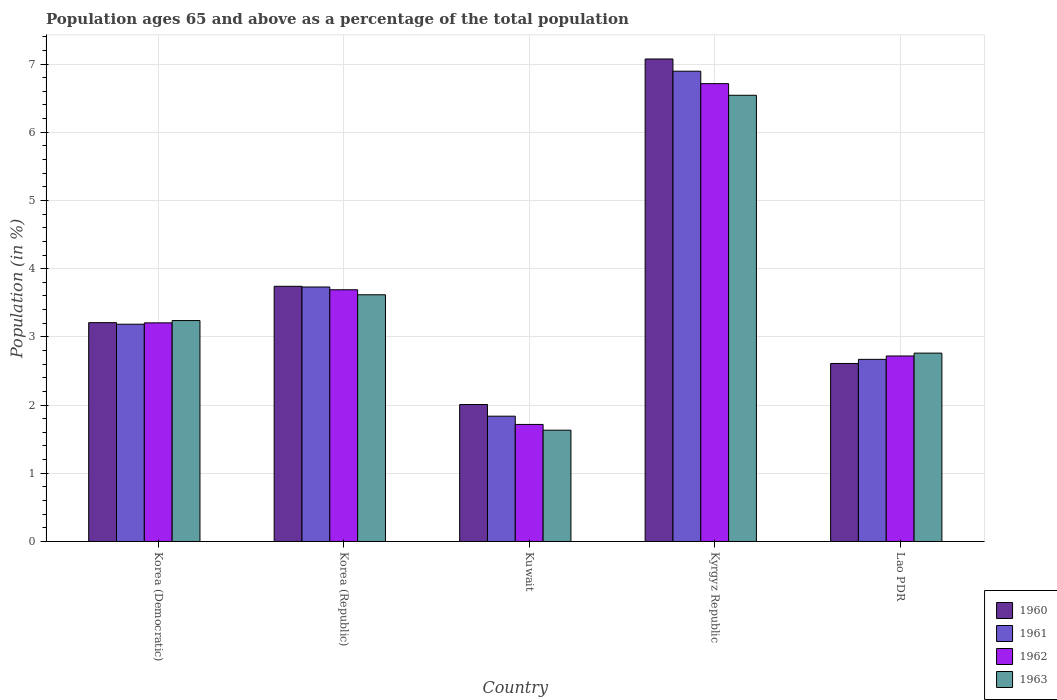How many groups of bars are there?
Offer a very short reply. 5. Are the number of bars on each tick of the X-axis equal?
Provide a short and direct response. Yes. How many bars are there on the 3rd tick from the left?
Ensure brevity in your answer.  4. What is the label of the 4th group of bars from the left?
Provide a short and direct response. Kyrgyz Republic. In how many cases, is the number of bars for a given country not equal to the number of legend labels?
Offer a very short reply. 0. What is the percentage of the population ages 65 and above in 1960 in Lao PDR?
Keep it short and to the point. 2.61. Across all countries, what is the maximum percentage of the population ages 65 and above in 1960?
Offer a very short reply. 7.07. Across all countries, what is the minimum percentage of the population ages 65 and above in 1960?
Make the answer very short. 2.01. In which country was the percentage of the population ages 65 and above in 1960 maximum?
Offer a terse response. Kyrgyz Republic. In which country was the percentage of the population ages 65 and above in 1960 minimum?
Provide a succinct answer. Kuwait. What is the total percentage of the population ages 65 and above in 1961 in the graph?
Make the answer very short. 18.32. What is the difference between the percentage of the population ages 65 and above in 1962 in Korea (Democratic) and that in Kyrgyz Republic?
Your response must be concise. -3.51. What is the difference between the percentage of the population ages 65 and above in 1963 in Kuwait and the percentage of the population ages 65 and above in 1962 in Lao PDR?
Your answer should be compact. -1.09. What is the average percentage of the population ages 65 and above in 1960 per country?
Offer a terse response. 3.73. What is the difference between the percentage of the population ages 65 and above of/in 1962 and percentage of the population ages 65 and above of/in 1961 in Korea (Democratic)?
Your answer should be very brief. 0.02. In how many countries, is the percentage of the population ages 65 and above in 1962 greater than 2.6?
Your answer should be compact. 4. What is the ratio of the percentage of the population ages 65 and above in 1960 in Korea (Republic) to that in Lao PDR?
Give a very brief answer. 1.43. Is the percentage of the population ages 65 and above in 1960 in Korea (Republic) less than that in Kyrgyz Republic?
Offer a terse response. Yes. What is the difference between the highest and the second highest percentage of the population ages 65 and above in 1963?
Your response must be concise. -0.38. What is the difference between the highest and the lowest percentage of the population ages 65 and above in 1960?
Provide a succinct answer. 5.07. In how many countries, is the percentage of the population ages 65 and above in 1962 greater than the average percentage of the population ages 65 and above in 1962 taken over all countries?
Keep it short and to the point. 2. Is it the case that in every country, the sum of the percentage of the population ages 65 and above in 1961 and percentage of the population ages 65 and above in 1960 is greater than the sum of percentage of the population ages 65 and above in 1963 and percentage of the population ages 65 and above in 1962?
Your response must be concise. No. What does the 4th bar from the left in Kyrgyz Republic represents?
Your answer should be compact. 1963. What does the 1st bar from the right in Kyrgyz Republic represents?
Offer a terse response. 1963. Are all the bars in the graph horizontal?
Offer a very short reply. No. How many countries are there in the graph?
Your answer should be compact. 5. What is the difference between two consecutive major ticks on the Y-axis?
Your answer should be compact. 1. Are the values on the major ticks of Y-axis written in scientific E-notation?
Your answer should be compact. No. What is the title of the graph?
Give a very brief answer. Population ages 65 and above as a percentage of the total population. What is the label or title of the X-axis?
Your answer should be compact. Country. What is the Population (in %) in 1960 in Korea (Democratic)?
Provide a short and direct response. 3.21. What is the Population (in %) in 1961 in Korea (Democratic)?
Your answer should be compact. 3.19. What is the Population (in %) in 1962 in Korea (Democratic)?
Make the answer very short. 3.21. What is the Population (in %) of 1963 in Korea (Democratic)?
Make the answer very short. 3.24. What is the Population (in %) of 1960 in Korea (Republic)?
Your answer should be very brief. 3.74. What is the Population (in %) of 1961 in Korea (Republic)?
Your answer should be very brief. 3.73. What is the Population (in %) of 1962 in Korea (Republic)?
Make the answer very short. 3.69. What is the Population (in %) in 1963 in Korea (Republic)?
Ensure brevity in your answer.  3.62. What is the Population (in %) of 1960 in Kuwait?
Keep it short and to the point. 2.01. What is the Population (in %) of 1961 in Kuwait?
Your answer should be compact. 1.84. What is the Population (in %) of 1962 in Kuwait?
Offer a terse response. 1.72. What is the Population (in %) in 1963 in Kuwait?
Your answer should be compact. 1.63. What is the Population (in %) of 1960 in Kyrgyz Republic?
Offer a very short reply. 7.07. What is the Population (in %) in 1961 in Kyrgyz Republic?
Offer a terse response. 6.9. What is the Population (in %) of 1962 in Kyrgyz Republic?
Keep it short and to the point. 6.71. What is the Population (in %) in 1963 in Kyrgyz Republic?
Provide a short and direct response. 6.54. What is the Population (in %) of 1960 in Lao PDR?
Ensure brevity in your answer.  2.61. What is the Population (in %) of 1961 in Lao PDR?
Your response must be concise. 2.67. What is the Population (in %) of 1962 in Lao PDR?
Provide a succinct answer. 2.72. What is the Population (in %) in 1963 in Lao PDR?
Give a very brief answer. 2.76. Across all countries, what is the maximum Population (in %) of 1960?
Offer a very short reply. 7.07. Across all countries, what is the maximum Population (in %) in 1961?
Keep it short and to the point. 6.9. Across all countries, what is the maximum Population (in %) of 1962?
Give a very brief answer. 6.71. Across all countries, what is the maximum Population (in %) in 1963?
Ensure brevity in your answer.  6.54. Across all countries, what is the minimum Population (in %) in 1960?
Keep it short and to the point. 2.01. Across all countries, what is the minimum Population (in %) in 1961?
Offer a terse response. 1.84. Across all countries, what is the minimum Population (in %) in 1962?
Ensure brevity in your answer.  1.72. Across all countries, what is the minimum Population (in %) in 1963?
Offer a terse response. 1.63. What is the total Population (in %) in 1960 in the graph?
Your answer should be very brief. 18.64. What is the total Population (in %) of 1961 in the graph?
Provide a succinct answer. 18.32. What is the total Population (in %) of 1962 in the graph?
Your answer should be compact. 18.05. What is the total Population (in %) of 1963 in the graph?
Keep it short and to the point. 17.79. What is the difference between the Population (in %) of 1960 in Korea (Democratic) and that in Korea (Republic)?
Offer a terse response. -0.53. What is the difference between the Population (in %) in 1961 in Korea (Democratic) and that in Korea (Republic)?
Ensure brevity in your answer.  -0.55. What is the difference between the Population (in %) of 1962 in Korea (Democratic) and that in Korea (Republic)?
Give a very brief answer. -0.49. What is the difference between the Population (in %) of 1963 in Korea (Democratic) and that in Korea (Republic)?
Keep it short and to the point. -0.38. What is the difference between the Population (in %) in 1960 in Korea (Democratic) and that in Kuwait?
Your response must be concise. 1.2. What is the difference between the Population (in %) in 1961 in Korea (Democratic) and that in Kuwait?
Ensure brevity in your answer.  1.35. What is the difference between the Population (in %) of 1962 in Korea (Democratic) and that in Kuwait?
Make the answer very short. 1.49. What is the difference between the Population (in %) in 1963 in Korea (Democratic) and that in Kuwait?
Keep it short and to the point. 1.61. What is the difference between the Population (in %) of 1960 in Korea (Democratic) and that in Kyrgyz Republic?
Provide a short and direct response. -3.87. What is the difference between the Population (in %) in 1961 in Korea (Democratic) and that in Kyrgyz Republic?
Make the answer very short. -3.71. What is the difference between the Population (in %) of 1962 in Korea (Democratic) and that in Kyrgyz Republic?
Offer a terse response. -3.51. What is the difference between the Population (in %) of 1963 in Korea (Democratic) and that in Kyrgyz Republic?
Ensure brevity in your answer.  -3.3. What is the difference between the Population (in %) in 1960 in Korea (Democratic) and that in Lao PDR?
Keep it short and to the point. 0.6. What is the difference between the Population (in %) in 1961 in Korea (Democratic) and that in Lao PDR?
Your answer should be compact. 0.52. What is the difference between the Population (in %) in 1962 in Korea (Democratic) and that in Lao PDR?
Make the answer very short. 0.49. What is the difference between the Population (in %) in 1963 in Korea (Democratic) and that in Lao PDR?
Keep it short and to the point. 0.48. What is the difference between the Population (in %) of 1960 in Korea (Republic) and that in Kuwait?
Provide a short and direct response. 1.73. What is the difference between the Population (in %) in 1961 in Korea (Republic) and that in Kuwait?
Keep it short and to the point. 1.89. What is the difference between the Population (in %) of 1962 in Korea (Republic) and that in Kuwait?
Offer a very short reply. 1.97. What is the difference between the Population (in %) in 1963 in Korea (Republic) and that in Kuwait?
Offer a very short reply. 1.99. What is the difference between the Population (in %) of 1960 in Korea (Republic) and that in Kyrgyz Republic?
Keep it short and to the point. -3.33. What is the difference between the Population (in %) in 1961 in Korea (Republic) and that in Kyrgyz Republic?
Give a very brief answer. -3.16. What is the difference between the Population (in %) of 1962 in Korea (Republic) and that in Kyrgyz Republic?
Give a very brief answer. -3.02. What is the difference between the Population (in %) of 1963 in Korea (Republic) and that in Kyrgyz Republic?
Your answer should be very brief. -2.93. What is the difference between the Population (in %) of 1960 in Korea (Republic) and that in Lao PDR?
Ensure brevity in your answer.  1.13. What is the difference between the Population (in %) in 1961 in Korea (Republic) and that in Lao PDR?
Keep it short and to the point. 1.06. What is the difference between the Population (in %) of 1962 in Korea (Republic) and that in Lao PDR?
Keep it short and to the point. 0.97. What is the difference between the Population (in %) of 1963 in Korea (Republic) and that in Lao PDR?
Ensure brevity in your answer.  0.86. What is the difference between the Population (in %) of 1960 in Kuwait and that in Kyrgyz Republic?
Offer a terse response. -5.07. What is the difference between the Population (in %) in 1961 in Kuwait and that in Kyrgyz Republic?
Give a very brief answer. -5.06. What is the difference between the Population (in %) in 1962 in Kuwait and that in Kyrgyz Republic?
Give a very brief answer. -5. What is the difference between the Population (in %) of 1963 in Kuwait and that in Kyrgyz Republic?
Provide a short and direct response. -4.91. What is the difference between the Population (in %) of 1960 in Kuwait and that in Lao PDR?
Offer a terse response. -0.6. What is the difference between the Population (in %) of 1961 in Kuwait and that in Lao PDR?
Provide a short and direct response. -0.83. What is the difference between the Population (in %) in 1962 in Kuwait and that in Lao PDR?
Your answer should be very brief. -1. What is the difference between the Population (in %) of 1963 in Kuwait and that in Lao PDR?
Your response must be concise. -1.13. What is the difference between the Population (in %) of 1960 in Kyrgyz Republic and that in Lao PDR?
Give a very brief answer. 4.46. What is the difference between the Population (in %) of 1961 in Kyrgyz Republic and that in Lao PDR?
Keep it short and to the point. 4.22. What is the difference between the Population (in %) of 1962 in Kyrgyz Republic and that in Lao PDR?
Offer a very short reply. 3.99. What is the difference between the Population (in %) of 1963 in Kyrgyz Republic and that in Lao PDR?
Your answer should be very brief. 3.78. What is the difference between the Population (in %) of 1960 in Korea (Democratic) and the Population (in %) of 1961 in Korea (Republic)?
Your answer should be very brief. -0.52. What is the difference between the Population (in %) in 1960 in Korea (Democratic) and the Population (in %) in 1962 in Korea (Republic)?
Give a very brief answer. -0.48. What is the difference between the Population (in %) of 1960 in Korea (Democratic) and the Population (in %) of 1963 in Korea (Republic)?
Offer a very short reply. -0.41. What is the difference between the Population (in %) in 1961 in Korea (Democratic) and the Population (in %) in 1962 in Korea (Republic)?
Your answer should be very brief. -0.51. What is the difference between the Population (in %) of 1961 in Korea (Democratic) and the Population (in %) of 1963 in Korea (Republic)?
Your answer should be very brief. -0.43. What is the difference between the Population (in %) of 1962 in Korea (Democratic) and the Population (in %) of 1963 in Korea (Republic)?
Offer a terse response. -0.41. What is the difference between the Population (in %) of 1960 in Korea (Democratic) and the Population (in %) of 1961 in Kuwait?
Give a very brief answer. 1.37. What is the difference between the Population (in %) of 1960 in Korea (Democratic) and the Population (in %) of 1962 in Kuwait?
Make the answer very short. 1.49. What is the difference between the Population (in %) of 1960 in Korea (Democratic) and the Population (in %) of 1963 in Kuwait?
Ensure brevity in your answer.  1.58. What is the difference between the Population (in %) of 1961 in Korea (Democratic) and the Population (in %) of 1962 in Kuwait?
Your answer should be compact. 1.47. What is the difference between the Population (in %) of 1961 in Korea (Democratic) and the Population (in %) of 1963 in Kuwait?
Your answer should be very brief. 1.55. What is the difference between the Population (in %) in 1962 in Korea (Democratic) and the Population (in %) in 1963 in Kuwait?
Ensure brevity in your answer.  1.57. What is the difference between the Population (in %) in 1960 in Korea (Democratic) and the Population (in %) in 1961 in Kyrgyz Republic?
Offer a very short reply. -3.69. What is the difference between the Population (in %) in 1960 in Korea (Democratic) and the Population (in %) in 1962 in Kyrgyz Republic?
Provide a short and direct response. -3.5. What is the difference between the Population (in %) of 1960 in Korea (Democratic) and the Population (in %) of 1963 in Kyrgyz Republic?
Keep it short and to the point. -3.33. What is the difference between the Population (in %) of 1961 in Korea (Democratic) and the Population (in %) of 1962 in Kyrgyz Republic?
Offer a very short reply. -3.53. What is the difference between the Population (in %) of 1961 in Korea (Democratic) and the Population (in %) of 1963 in Kyrgyz Republic?
Provide a succinct answer. -3.36. What is the difference between the Population (in %) of 1962 in Korea (Democratic) and the Population (in %) of 1963 in Kyrgyz Republic?
Give a very brief answer. -3.34. What is the difference between the Population (in %) of 1960 in Korea (Democratic) and the Population (in %) of 1961 in Lao PDR?
Give a very brief answer. 0.54. What is the difference between the Population (in %) in 1960 in Korea (Democratic) and the Population (in %) in 1962 in Lao PDR?
Keep it short and to the point. 0.49. What is the difference between the Population (in %) in 1960 in Korea (Democratic) and the Population (in %) in 1963 in Lao PDR?
Keep it short and to the point. 0.45. What is the difference between the Population (in %) in 1961 in Korea (Democratic) and the Population (in %) in 1962 in Lao PDR?
Provide a succinct answer. 0.47. What is the difference between the Population (in %) of 1961 in Korea (Democratic) and the Population (in %) of 1963 in Lao PDR?
Your answer should be compact. 0.42. What is the difference between the Population (in %) in 1962 in Korea (Democratic) and the Population (in %) in 1963 in Lao PDR?
Keep it short and to the point. 0.44. What is the difference between the Population (in %) of 1960 in Korea (Republic) and the Population (in %) of 1961 in Kuwait?
Provide a succinct answer. 1.9. What is the difference between the Population (in %) of 1960 in Korea (Republic) and the Population (in %) of 1962 in Kuwait?
Provide a succinct answer. 2.03. What is the difference between the Population (in %) in 1960 in Korea (Republic) and the Population (in %) in 1963 in Kuwait?
Provide a succinct answer. 2.11. What is the difference between the Population (in %) in 1961 in Korea (Republic) and the Population (in %) in 1962 in Kuwait?
Ensure brevity in your answer.  2.02. What is the difference between the Population (in %) of 1961 in Korea (Republic) and the Population (in %) of 1963 in Kuwait?
Keep it short and to the point. 2.1. What is the difference between the Population (in %) in 1962 in Korea (Republic) and the Population (in %) in 1963 in Kuwait?
Ensure brevity in your answer.  2.06. What is the difference between the Population (in %) in 1960 in Korea (Republic) and the Population (in %) in 1961 in Kyrgyz Republic?
Your answer should be very brief. -3.15. What is the difference between the Population (in %) of 1960 in Korea (Republic) and the Population (in %) of 1962 in Kyrgyz Republic?
Keep it short and to the point. -2.97. What is the difference between the Population (in %) of 1960 in Korea (Republic) and the Population (in %) of 1963 in Kyrgyz Republic?
Provide a succinct answer. -2.8. What is the difference between the Population (in %) of 1961 in Korea (Republic) and the Population (in %) of 1962 in Kyrgyz Republic?
Offer a terse response. -2.98. What is the difference between the Population (in %) of 1961 in Korea (Republic) and the Population (in %) of 1963 in Kyrgyz Republic?
Make the answer very short. -2.81. What is the difference between the Population (in %) of 1962 in Korea (Republic) and the Population (in %) of 1963 in Kyrgyz Republic?
Offer a very short reply. -2.85. What is the difference between the Population (in %) in 1960 in Korea (Republic) and the Population (in %) in 1961 in Lao PDR?
Ensure brevity in your answer.  1.07. What is the difference between the Population (in %) in 1960 in Korea (Republic) and the Population (in %) in 1962 in Lao PDR?
Your answer should be compact. 1.02. What is the difference between the Population (in %) in 1960 in Korea (Republic) and the Population (in %) in 1963 in Lao PDR?
Your answer should be compact. 0.98. What is the difference between the Population (in %) of 1961 in Korea (Republic) and the Population (in %) of 1962 in Lao PDR?
Provide a succinct answer. 1.01. What is the difference between the Population (in %) in 1961 in Korea (Republic) and the Population (in %) in 1963 in Lao PDR?
Make the answer very short. 0.97. What is the difference between the Population (in %) in 1962 in Korea (Republic) and the Population (in %) in 1963 in Lao PDR?
Give a very brief answer. 0.93. What is the difference between the Population (in %) in 1960 in Kuwait and the Population (in %) in 1961 in Kyrgyz Republic?
Your answer should be compact. -4.89. What is the difference between the Population (in %) of 1960 in Kuwait and the Population (in %) of 1962 in Kyrgyz Republic?
Provide a short and direct response. -4.7. What is the difference between the Population (in %) of 1960 in Kuwait and the Population (in %) of 1963 in Kyrgyz Republic?
Give a very brief answer. -4.53. What is the difference between the Population (in %) of 1961 in Kuwait and the Population (in %) of 1962 in Kyrgyz Republic?
Keep it short and to the point. -4.88. What is the difference between the Population (in %) of 1961 in Kuwait and the Population (in %) of 1963 in Kyrgyz Republic?
Ensure brevity in your answer.  -4.71. What is the difference between the Population (in %) of 1962 in Kuwait and the Population (in %) of 1963 in Kyrgyz Republic?
Give a very brief answer. -4.83. What is the difference between the Population (in %) of 1960 in Kuwait and the Population (in %) of 1961 in Lao PDR?
Provide a short and direct response. -0.66. What is the difference between the Population (in %) of 1960 in Kuwait and the Population (in %) of 1962 in Lao PDR?
Give a very brief answer. -0.71. What is the difference between the Population (in %) in 1960 in Kuwait and the Population (in %) in 1963 in Lao PDR?
Your answer should be compact. -0.75. What is the difference between the Population (in %) in 1961 in Kuwait and the Population (in %) in 1962 in Lao PDR?
Offer a very short reply. -0.88. What is the difference between the Population (in %) of 1961 in Kuwait and the Population (in %) of 1963 in Lao PDR?
Your response must be concise. -0.92. What is the difference between the Population (in %) of 1962 in Kuwait and the Population (in %) of 1963 in Lao PDR?
Your answer should be very brief. -1.05. What is the difference between the Population (in %) of 1960 in Kyrgyz Republic and the Population (in %) of 1961 in Lao PDR?
Your answer should be very brief. 4.4. What is the difference between the Population (in %) of 1960 in Kyrgyz Republic and the Population (in %) of 1962 in Lao PDR?
Your answer should be very brief. 4.35. What is the difference between the Population (in %) in 1960 in Kyrgyz Republic and the Population (in %) in 1963 in Lao PDR?
Give a very brief answer. 4.31. What is the difference between the Population (in %) of 1961 in Kyrgyz Republic and the Population (in %) of 1962 in Lao PDR?
Provide a short and direct response. 4.18. What is the difference between the Population (in %) of 1961 in Kyrgyz Republic and the Population (in %) of 1963 in Lao PDR?
Your response must be concise. 4.13. What is the difference between the Population (in %) in 1962 in Kyrgyz Republic and the Population (in %) in 1963 in Lao PDR?
Keep it short and to the point. 3.95. What is the average Population (in %) of 1960 per country?
Ensure brevity in your answer.  3.73. What is the average Population (in %) of 1961 per country?
Keep it short and to the point. 3.66. What is the average Population (in %) in 1962 per country?
Give a very brief answer. 3.61. What is the average Population (in %) in 1963 per country?
Offer a terse response. 3.56. What is the difference between the Population (in %) in 1960 and Population (in %) in 1961 in Korea (Democratic)?
Your response must be concise. 0.02. What is the difference between the Population (in %) of 1960 and Population (in %) of 1962 in Korea (Democratic)?
Provide a succinct answer. 0. What is the difference between the Population (in %) in 1960 and Population (in %) in 1963 in Korea (Democratic)?
Give a very brief answer. -0.03. What is the difference between the Population (in %) of 1961 and Population (in %) of 1962 in Korea (Democratic)?
Your answer should be compact. -0.02. What is the difference between the Population (in %) in 1961 and Population (in %) in 1963 in Korea (Democratic)?
Provide a short and direct response. -0.05. What is the difference between the Population (in %) in 1962 and Population (in %) in 1963 in Korea (Democratic)?
Keep it short and to the point. -0.03. What is the difference between the Population (in %) of 1960 and Population (in %) of 1961 in Korea (Republic)?
Offer a very short reply. 0.01. What is the difference between the Population (in %) in 1960 and Population (in %) in 1962 in Korea (Republic)?
Your response must be concise. 0.05. What is the difference between the Population (in %) in 1960 and Population (in %) in 1963 in Korea (Republic)?
Keep it short and to the point. 0.12. What is the difference between the Population (in %) in 1961 and Population (in %) in 1962 in Korea (Republic)?
Provide a succinct answer. 0.04. What is the difference between the Population (in %) of 1961 and Population (in %) of 1963 in Korea (Republic)?
Your answer should be compact. 0.11. What is the difference between the Population (in %) of 1962 and Population (in %) of 1963 in Korea (Republic)?
Ensure brevity in your answer.  0.07. What is the difference between the Population (in %) of 1960 and Population (in %) of 1961 in Kuwait?
Provide a succinct answer. 0.17. What is the difference between the Population (in %) of 1960 and Population (in %) of 1962 in Kuwait?
Your response must be concise. 0.29. What is the difference between the Population (in %) of 1960 and Population (in %) of 1963 in Kuwait?
Keep it short and to the point. 0.38. What is the difference between the Population (in %) in 1961 and Population (in %) in 1962 in Kuwait?
Provide a short and direct response. 0.12. What is the difference between the Population (in %) of 1961 and Population (in %) of 1963 in Kuwait?
Offer a terse response. 0.21. What is the difference between the Population (in %) in 1962 and Population (in %) in 1963 in Kuwait?
Provide a succinct answer. 0.08. What is the difference between the Population (in %) in 1960 and Population (in %) in 1961 in Kyrgyz Republic?
Your answer should be compact. 0.18. What is the difference between the Population (in %) in 1960 and Population (in %) in 1962 in Kyrgyz Republic?
Ensure brevity in your answer.  0.36. What is the difference between the Population (in %) in 1960 and Population (in %) in 1963 in Kyrgyz Republic?
Make the answer very short. 0.53. What is the difference between the Population (in %) in 1961 and Population (in %) in 1962 in Kyrgyz Republic?
Your answer should be very brief. 0.18. What is the difference between the Population (in %) in 1961 and Population (in %) in 1963 in Kyrgyz Republic?
Your answer should be compact. 0.35. What is the difference between the Population (in %) of 1962 and Population (in %) of 1963 in Kyrgyz Republic?
Provide a succinct answer. 0.17. What is the difference between the Population (in %) in 1960 and Population (in %) in 1961 in Lao PDR?
Provide a succinct answer. -0.06. What is the difference between the Population (in %) in 1960 and Population (in %) in 1962 in Lao PDR?
Offer a terse response. -0.11. What is the difference between the Population (in %) in 1960 and Population (in %) in 1963 in Lao PDR?
Offer a terse response. -0.15. What is the difference between the Population (in %) of 1961 and Population (in %) of 1962 in Lao PDR?
Your answer should be compact. -0.05. What is the difference between the Population (in %) in 1961 and Population (in %) in 1963 in Lao PDR?
Offer a very short reply. -0.09. What is the difference between the Population (in %) in 1962 and Population (in %) in 1963 in Lao PDR?
Offer a terse response. -0.04. What is the ratio of the Population (in %) of 1960 in Korea (Democratic) to that in Korea (Republic)?
Your answer should be very brief. 0.86. What is the ratio of the Population (in %) in 1961 in Korea (Democratic) to that in Korea (Republic)?
Ensure brevity in your answer.  0.85. What is the ratio of the Population (in %) of 1962 in Korea (Democratic) to that in Korea (Republic)?
Offer a very short reply. 0.87. What is the ratio of the Population (in %) in 1963 in Korea (Democratic) to that in Korea (Republic)?
Your answer should be compact. 0.9. What is the ratio of the Population (in %) of 1960 in Korea (Democratic) to that in Kuwait?
Offer a very short reply. 1.6. What is the ratio of the Population (in %) of 1961 in Korea (Democratic) to that in Kuwait?
Make the answer very short. 1.73. What is the ratio of the Population (in %) in 1962 in Korea (Democratic) to that in Kuwait?
Offer a terse response. 1.87. What is the ratio of the Population (in %) in 1963 in Korea (Democratic) to that in Kuwait?
Ensure brevity in your answer.  1.99. What is the ratio of the Population (in %) of 1960 in Korea (Democratic) to that in Kyrgyz Republic?
Provide a succinct answer. 0.45. What is the ratio of the Population (in %) in 1961 in Korea (Democratic) to that in Kyrgyz Republic?
Your answer should be very brief. 0.46. What is the ratio of the Population (in %) in 1962 in Korea (Democratic) to that in Kyrgyz Republic?
Your response must be concise. 0.48. What is the ratio of the Population (in %) of 1963 in Korea (Democratic) to that in Kyrgyz Republic?
Give a very brief answer. 0.5. What is the ratio of the Population (in %) of 1960 in Korea (Democratic) to that in Lao PDR?
Provide a short and direct response. 1.23. What is the ratio of the Population (in %) of 1961 in Korea (Democratic) to that in Lao PDR?
Provide a short and direct response. 1.19. What is the ratio of the Population (in %) of 1962 in Korea (Democratic) to that in Lao PDR?
Ensure brevity in your answer.  1.18. What is the ratio of the Population (in %) in 1963 in Korea (Democratic) to that in Lao PDR?
Ensure brevity in your answer.  1.17. What is the ratio of the Population (in %) of 1960 in Korea (Republic) to that in Kuwait?
Offer a terse response. 1.86. What is the ratio of the Population (in %) in 1961 in Korea (Republic) to that in Kuwait?
Keep it short and to the point. 2.03. What is the ratio of the Population (in %) in 1962 in Korea (Republic) to that in Kuwait?
Your answer should be compact. 2.15. What is the ratio of the Population (in %) in 1963 in Korea (Republic) to that in Kuwait?
Offer a terse response. 2.22. What is the ratio of the Population (in %) in 1960 in Korea (Republic) to that in Kyrgyz Republic?
Your answer should be compact. 0.53. What is the ratio of the Population (in %) in 1961 in Korea (Republic) to that in Kyrgyz Republic?
Give a very brief answer. 0.54. What is the ratio of the Population (in %) of 1962 in Korea (Republic) to that in Kyrgyz Republic?
Provide a succinct answer. 0.55. What is the ratio of the Population (in %) of 1963 in Korea (Republic) to that in Kyrgyz Republic?
Make the answer very short. 0.55. What is the ratio of the Population (in %) of 1960 in Korea (Republic) to that in Lao PDR?
Offer a terse response. 1.43. What is the ratio of the Population (in %) of 1961 in Korea (Republic) to that in Lao PDR?
Offer a terse response. 1.4. What is the ratio of the Population (in %) in 1962 in Korea (Republic) to that in Lao PDR?
Your answer should be very brief. 1.36. What is the ratio of the Population (in %) of 1963 in Korea (Republic) to that in Lao PDR?
Provide a succinct answer. 1.31. What is the ratio of the Population (in %) of 1960 in Kuwait to that in Kyrgyz Republic?
Make the answer very short. 0.28. What is the ratio of the Population (in %) of 1961 in Kuwait to that in Kyrgyz Republic?
Provide a short and direct response. 0.27. What is the ratio of the Population (in %) in 1962 in Kuwait to that in Kyrgyz Republic?
Your answer should be compact. 0.26. What is the ratio of the Population (in %) in 1963 in Kuwait to that in Kyrgyz Republic?
Your answer should be compact. 0.25. What is the ratio of the Population (in %) of 1960 in Kuwait to that in Lao PDR?
Offer a terse response. 0.77. What is the ratio of the Population (in %) in 1961 in Kuwait to that in Lao PDR?
Your answer should be very brief. 0.69. What is the ratio of the Population (in %) of 1962 in Kuwait to that in Lao PDR?
Your answer should be compact. 0.63. What is the ratio of the Population (in %) in 1963 in Kuwait to that in Lao PDR?
Ensure brevity in your answer.  0.59. What is the ratio of the Population (in %) of 1960 in Kyrgyz Republic to that in Lao PDR?
Offer a terse response. 2.71. What is the ratio of the Population (in %) in 1961 in Kyrgyz Republic to that in Lao PDR?
Offer a terse response. 2.58. What is the ratio of the Population (in %) in 1962 in Kyrgyz Republic to that in Lao PDR?
Keep it short and to the point. 2.47. What is the ratio of the Population (in %) of 1963 in Kyrgyz Republic to that in Lao PDR?
Provide a succinct answer. 2.37. What is the difference between the highest and the second highest Population (in %) in 1960?
Your response must be concise. 3.33. What is the difference between the highest and the second highest Population (in %) in 1961?
Offer a very short reply. 3.16. What is the difference between the highest and the second highest Population (in %) in 1962?
Offer a very short reply. 3.02. What is the difference between the highest and the second highest Population (in %) in 1963?
Your response must be concise. 2.93. What is the difference between the highest and the lowest Population (in %) in 1960?
Offer a very short reply. 5.07. What is the difference between the highest and the lowest Population (in %) of 1961?
Ensure brevity in your answer.  5.06. What is the difference between the highest and the lowest Population (in %) of 1962?
Keep it short and to the point. 5. What is the difference between the highest and the lowest Population (in %) in 1963?
Offer a terse response. 4.91. 